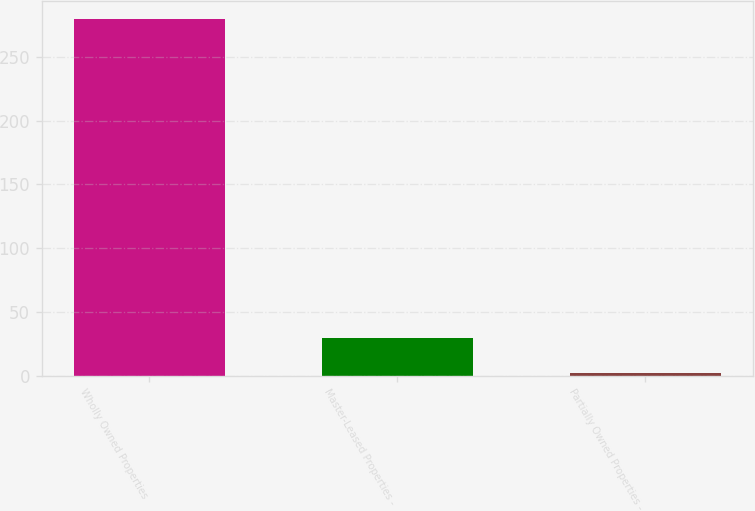Convert chart. <chart><loc_0><loc_0><loc_500><loc_500><bar_chart><fcel>Wholly Owned Properties<fcel>Master-Leased Properties -<fcel>Partially Owned Properties -<nl><fcel>280<fcel>29.8<fcel>2<nl></chart> 